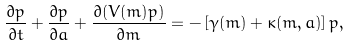<formula> <loc_0><loc_0><loc_500><loc_500>\frac { \partial p } { \partial t } + \frac { \partial p } { \partial a } + \frac { \partial ( V ( m ) p ) } { \partial m } = - \left [ \gamma ( m ) + \kappa ( m , a ) \right ] p ,</formula> 